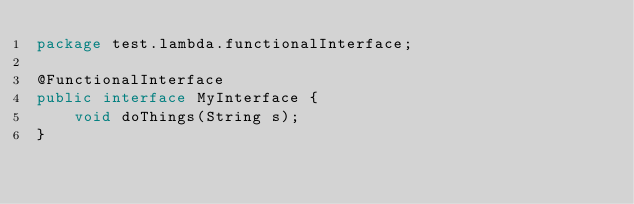Convert code to text. <code><loc_0><loc_0><loc_500><loc_500><_Java_>package test.lambda.functionalInterface;

@FunctionalInterface
public interface MyInterface {
    void doThings(String s);
}
</code> 